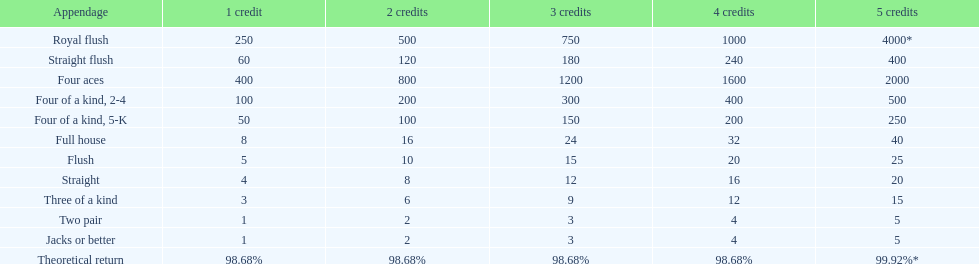What is the total amount of a 3 credit straight flush? 180. 